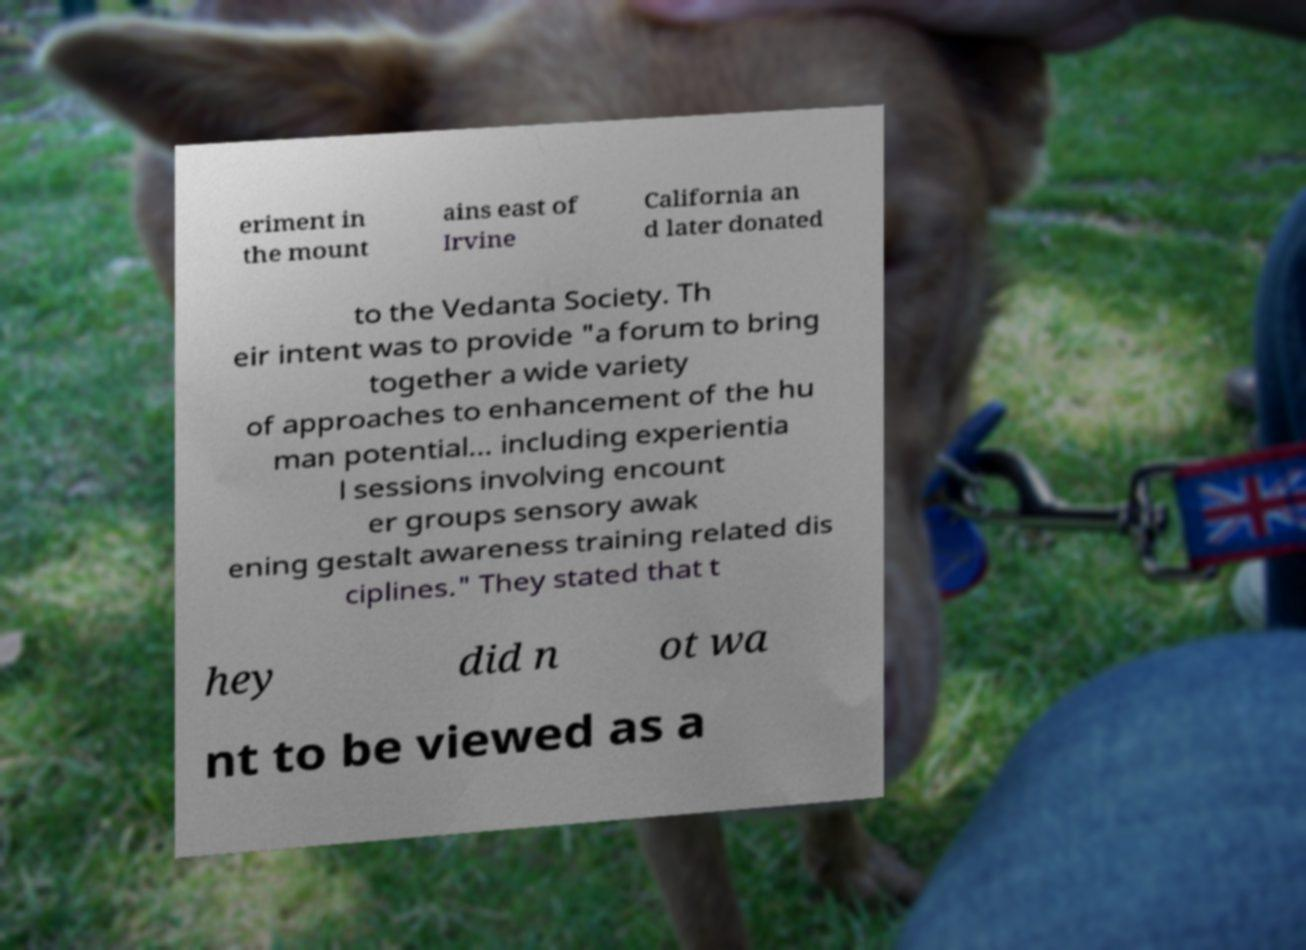Can you accurately transcribe the text from the provided image for me? eriment in the mount ains east of Irvine California an d later donated to the Vedanta Society. Th eir intent was to provide "a forum to bring together a wide variety of approaches to enhancement of the hu man potential... including experientia l sessions involving encount er groups sensory awak ening gestalt awareness training related dis ciplines." They stated that t hey did n ot wa nt to be viewed as a 